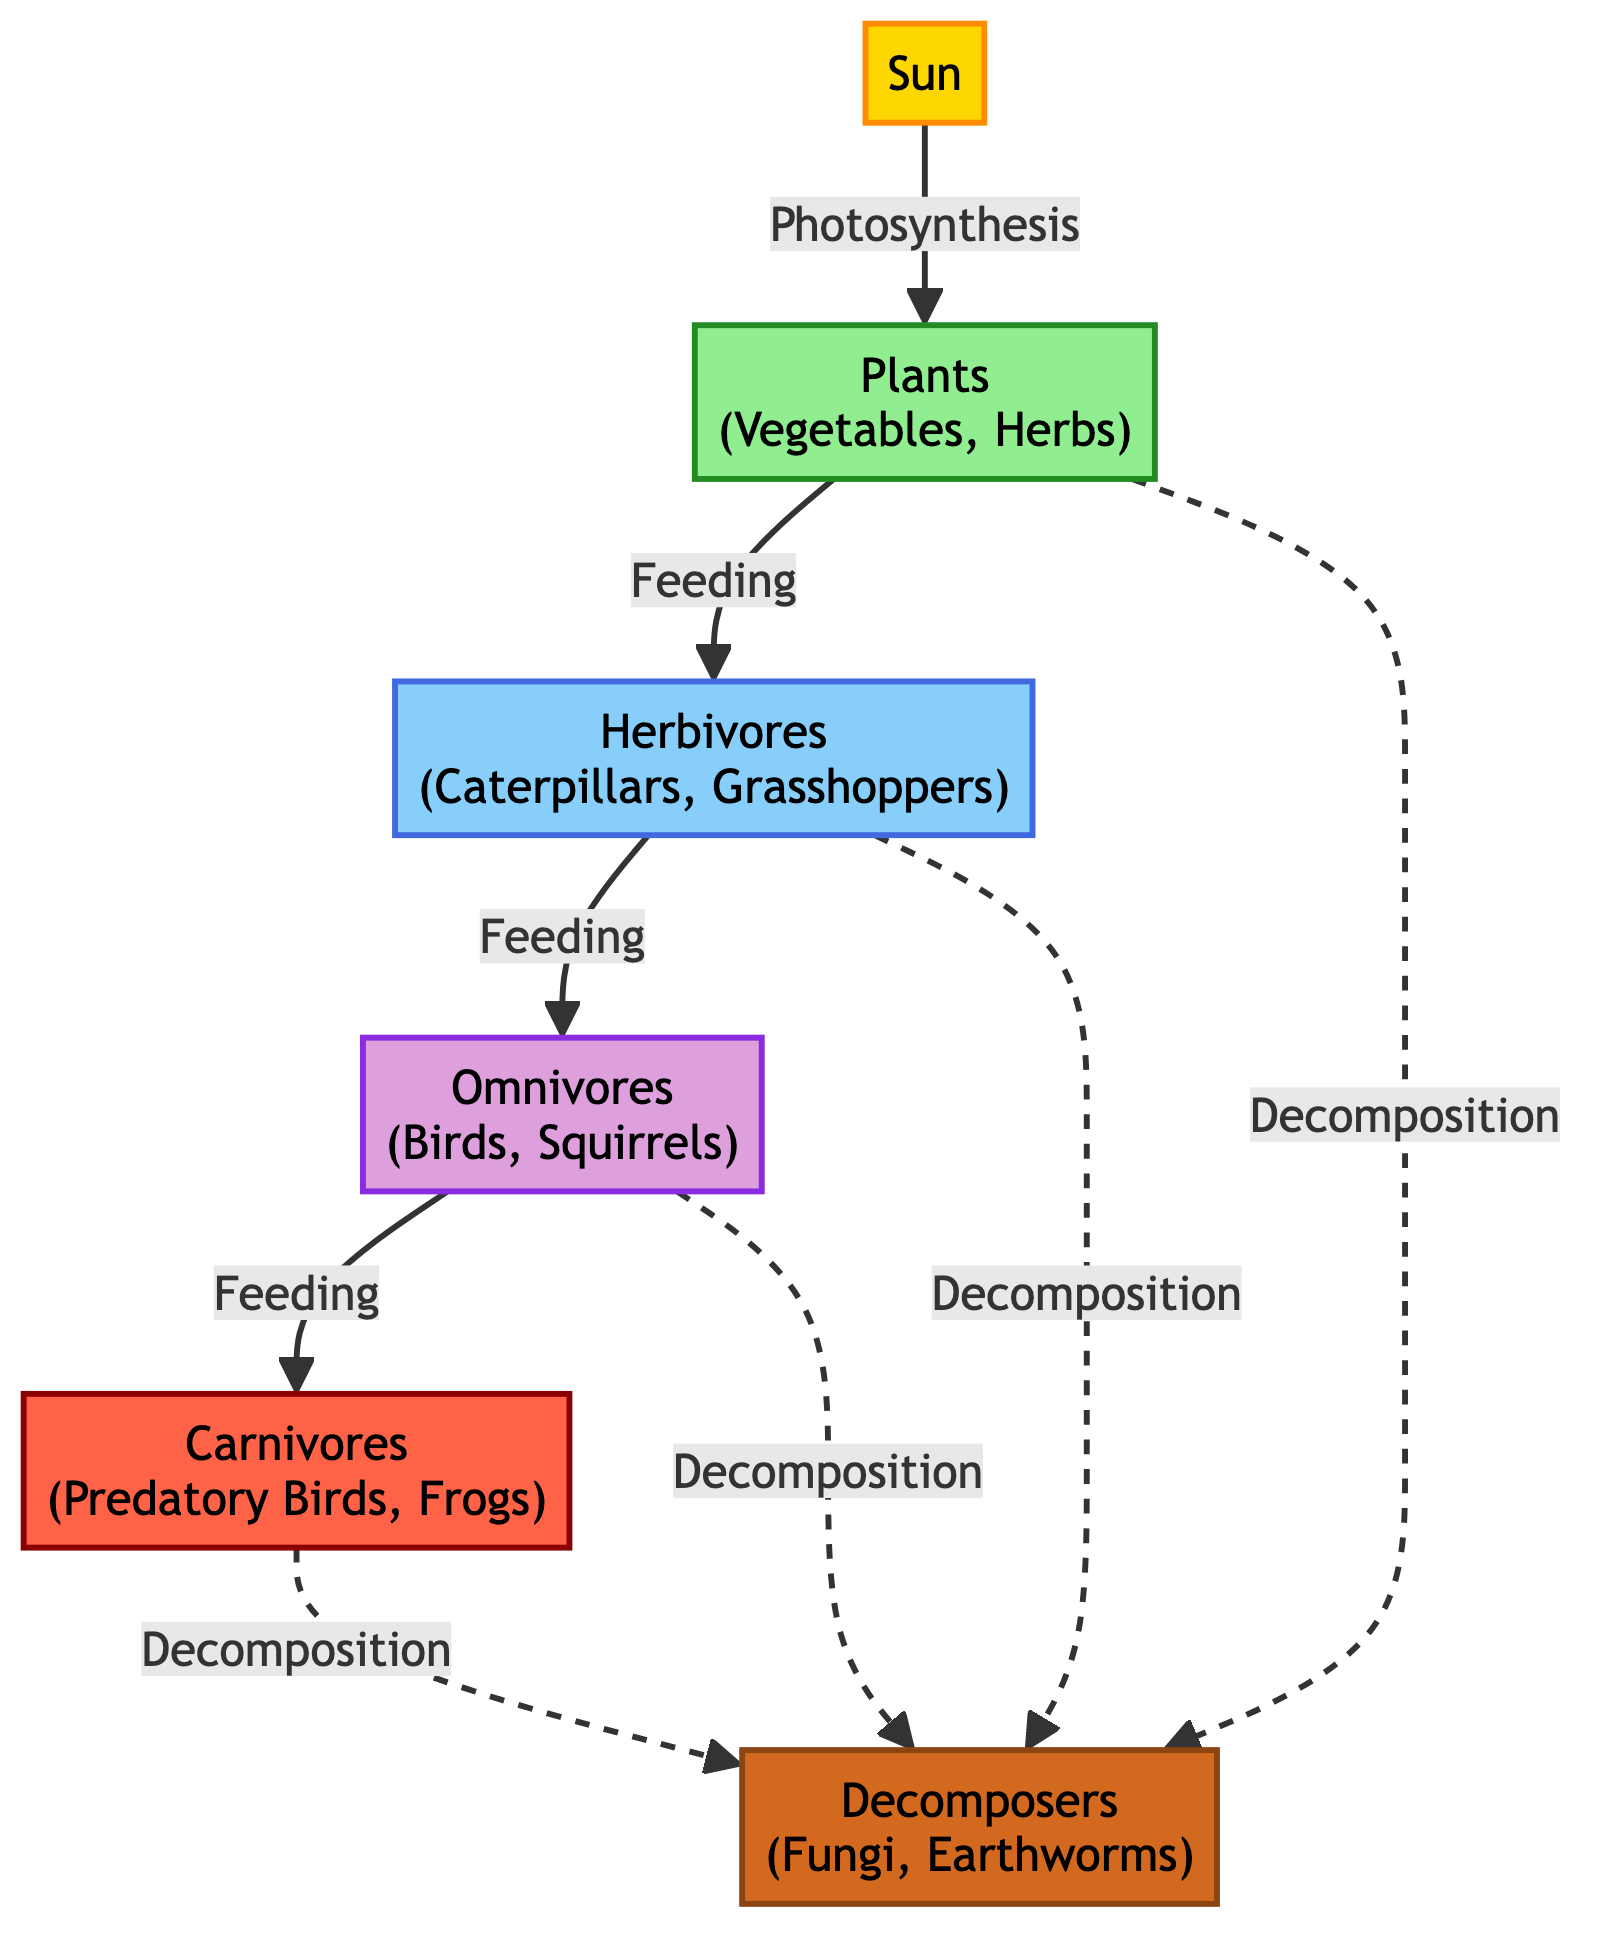What is the primary source of energy in this food chain? The diagram indicates that the primary source of energy in this food chain is represented by the "Sun." There are no alternative energy sources indicated, confirming it as the main energy provider.
Answer: Sun How many primary consumers are in the food chain? The diagram shows the nodes for primary consumers as "Herbivores," specifically "Caterpillars" and "Grasshoppers." Counting these gives a total of two primary consumers in the chain.
Answer: 2 Which group feeds on herbivores? According to the diagram, the arrow showing the feeding relationship indicates that the "Omnivores" feed on the "Herbivores." The direction of the arrows denotes the feeding flow, confirming this relationship.
Answer: Omnivores What role do decomposers play in this food chain? Decomposers, such as "Fungi" and "Earthworms," break down organic matter from all other groups after they decompose, as shown by the dashed arrows leading from all categories to the decomposers in the diagram. Their role is essential for nutrient cycling.
Answer: Decomposition Identify one type of carnivore in the food chain. The diagram lists "Predatory Birds" and "Frogs" as examples of carnivores. Either one would answer the question, but choosing "Predatory Birds" from the diagram directly fulfills the condition.
Answer: Predatory Birds What type of consumers are birds categorized under in this food chain? The diagram indicates that birds are in the group labeled as "Omnivores," indicating they consume plants as well as other animals, specifically herbivores in this context. Therefore, the answer is derived directly from the classification shown in the diagram.
Answer: Omnivores How does energy flow from plants to primary consumers? Energy flows from "Plants" to "Herbivores" via a direct feeding relationship, as shown by a solid arrow indicating that herbivores eat plants, thus transferring energy according to the diagram's flow.
Answer: Feeding How many levels are there in the food chain? The food chain consists of five levels: "Sun," "Plants," "Herbivores," "Omnivores," and "Carnivores." This indicates the hierarchy of energy flow from the primary energy source down to the tertiary consumers. By counting these categories, we find there are five levels.
Answer: 5 